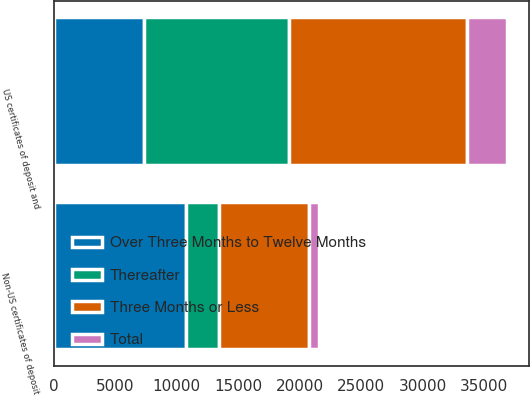Convert chart to OTSL. <chart><loc_0><loc_0><loc_500><loc_500><stacked_bar_chart><ecel><fcel>US certificates of deposit and<fcel>Non-US certificates of deposit<nl><fcel>Three Months or Less<fcel>14441<fcel>7317<nl><fcel>Thereafter<fcel>11855<fcel>2655<nl><fcel>Total<fcel>3209<fcel>820<nl><fcel>Over Three Months to Twelve Months<fcel>7317<fcel>10792<nl></chart> 